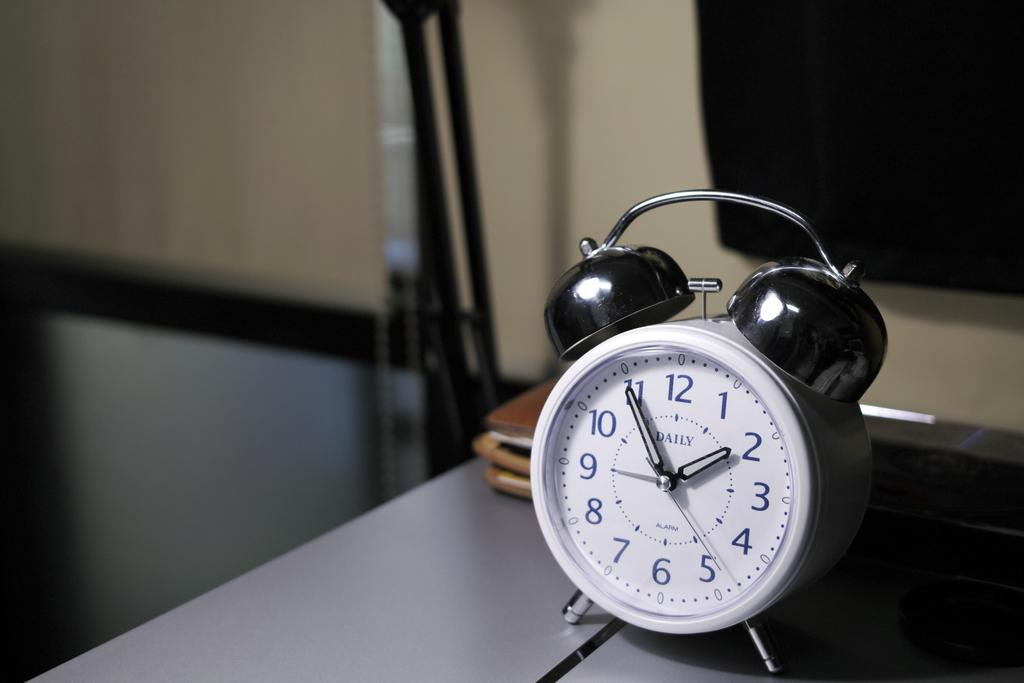<image>
Describe the image concisely. An old clock shows that it is 1:55. 